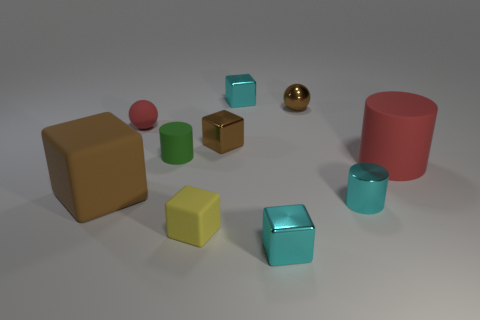How many objects are there in total in the image? There are a total of nine objects in the image, including various geometric shapes and cylinders of different sizes and colors. 